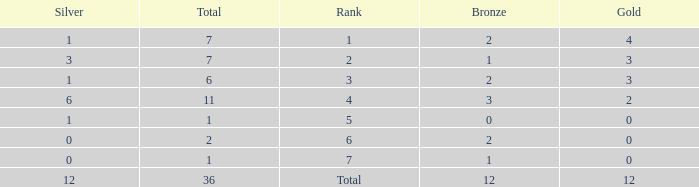What is the largest total for a team with 1 bronze, 0 gold medals and ranking of 7? None. 